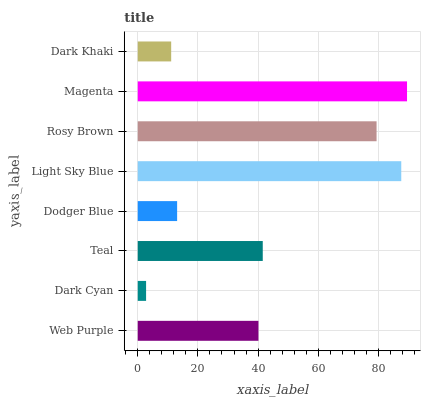Is Dark Cyan the minimum?
Answer yes or no. Yes. Is Magenta the maximum?
Answer yes or no. Yes. Is Teal the minimum?
Answer yes or no. No. Is Teal the maximum?
Answer yes or no. No. Is Teal greater than Dark Cyan?
Answer yes or no. Yes. Is Dark Cyan less than Teal?
Answer yes or no. Yes. Is Dark Cyan greater than Teal?
Answer yes or no. No. Is Teal less than Dark Cyan?
Answer yes or no. No. Is Teal the high median?
Answer yes or no. Yes. Is Web Purple the low median?
Answer yes or no. Yes. Is Dark Cyan the high median?
Answer yes or no. No. Is Magenta the low median?
Answer yes or no. No. 